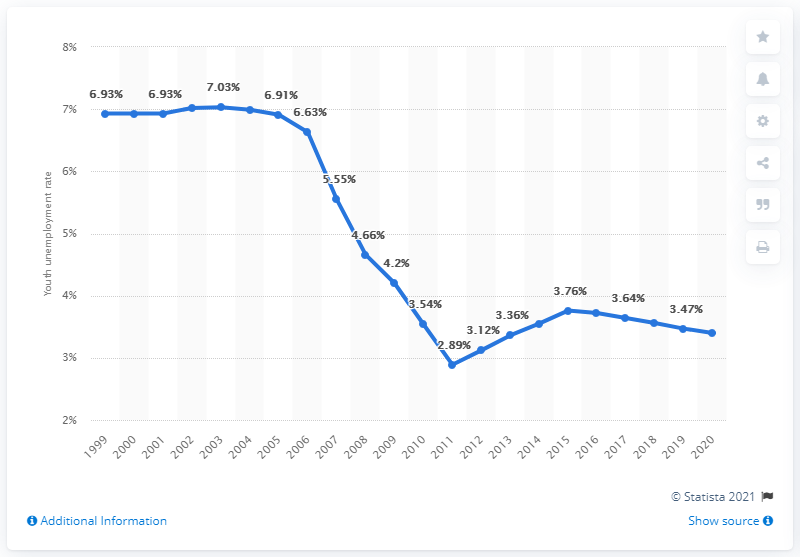Mention a couple of crucial points in this snapshot. In 2020, the youth unemployment rate in Togo was 3.4%. 